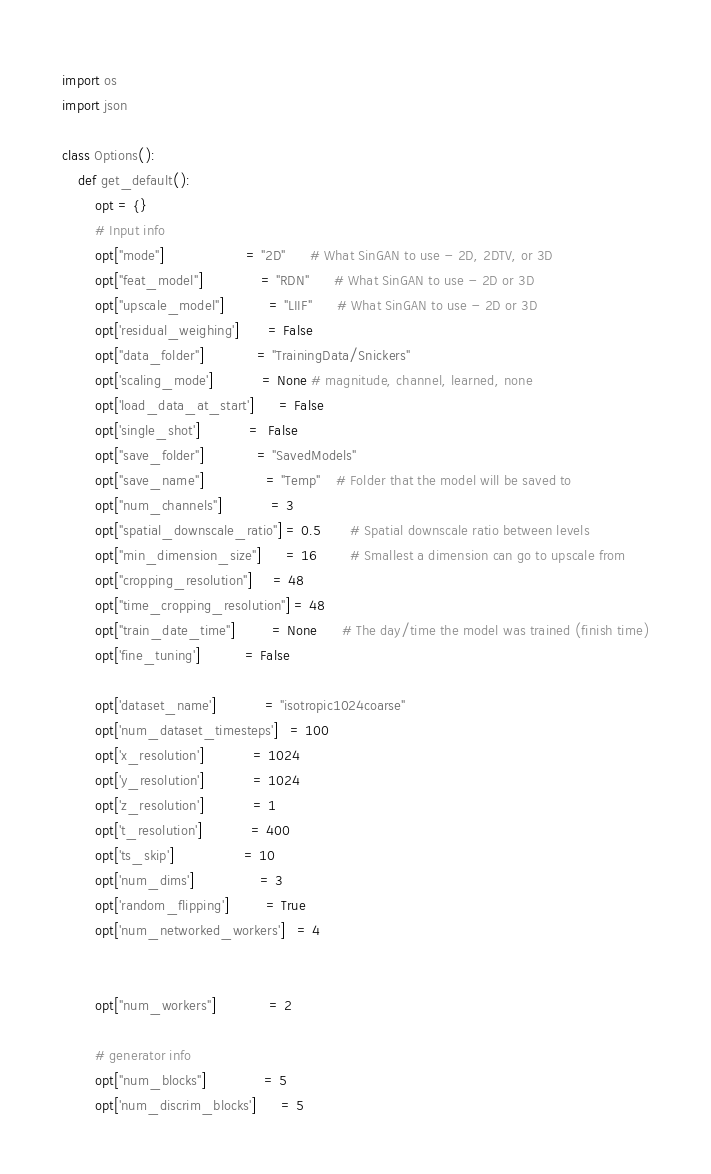<code> <loc_0><loc_0><loc_500><loc_500><_Python_>import os
import json

class Options():
    def get_default():
        opt = {}
        # Input info
        opt["mode"]                    = "2D"      # What SinGAN to use - 2D, 2DTV, or 3D
        opt["feat_model"]              = "RDN"      # What SinGAN to use - 2D or 3D
        opt["upscale_model"]           = "LIIF"      # What SinGAN to use - 2D or 3D
        opt['residual_weighing']       = False
        opt["data_folder"]             = "TrainingData/Snickers"
        opt['scaling_mode']            = None # magnitude, channel, learned, none
        opt['load_data_at_start']      = False
        opt['single_shot']            =  False
        opt["save_folder"]             = "SavedModels"
        opt["save_name"]               = "Temp"    # Folder that the model will be saved to
        opt["num_channels"]            = 3
        opt["spatial_downscale_ratio"] = 0.5       # Spatial downscale ratio between levels
        opt["min_dimension_size"]      = 16        # Smallest a dimension can go to upscale from
        opt["cropping_resolution"]     = 48
        opt["time_cropping_resolution"] = 48
        opt["train_date_time"]         = None      # The day/time the model was trained (finish time)
        opt['fine_tuning']           = False

        opt['dataset_name']            = "isotropic1024coarse"
        opt['num_dataset_timesteps']   = 100
        opt['x_resolution']            = 1024
        opt['y_resolution']            = 1024
        opt['z_resolution']            = 1
        opt['t_resolution']            = 400
        opt['ts_skip']                 = 10
        opt['num_dims']                = 3
        opt['random_flipping']         = True
        opt['num_networked_workers']   = 4


        opt["num_workers"]             = 2

        # generator info
        opt["num_blocks"]              = 5
        opt['num_discrim_blocks']      = 5</code> 